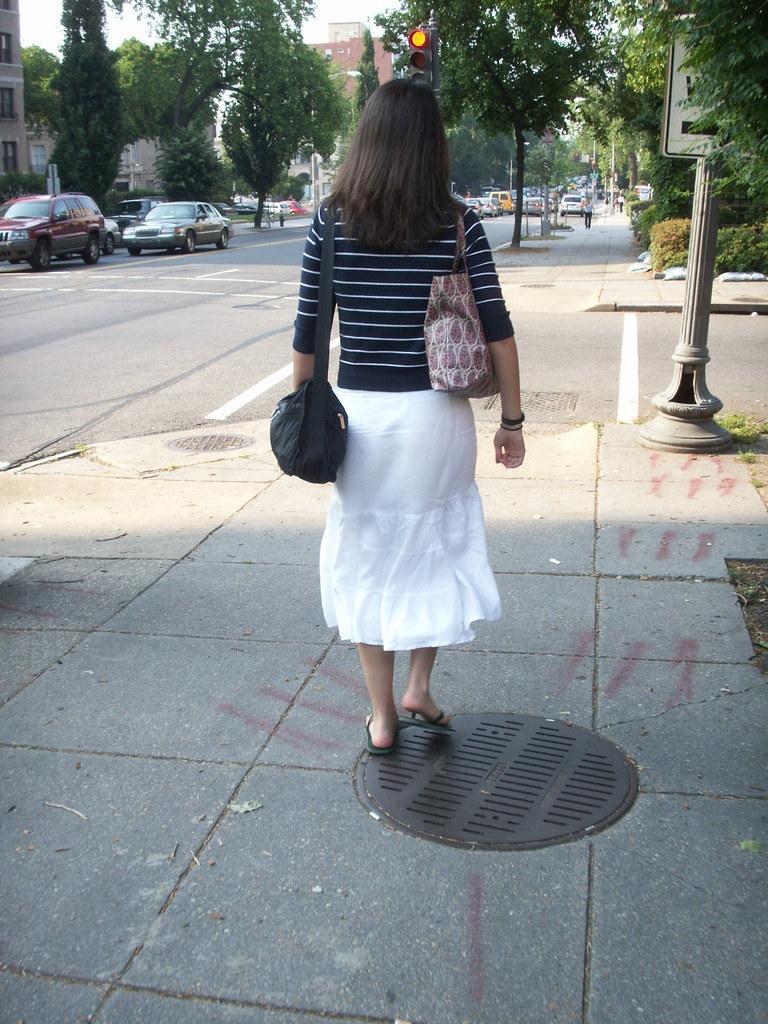How would you summarize this image in a sentence or two? In this image, there are a few people. Among them, we can see a lady carrying bag. We can see the ground with some objects. There are a few vehicles, trees, plants. We can also see some grass and a pole with a board. There are a few houses. We can also see the sky. We can also see some traffic lights. 